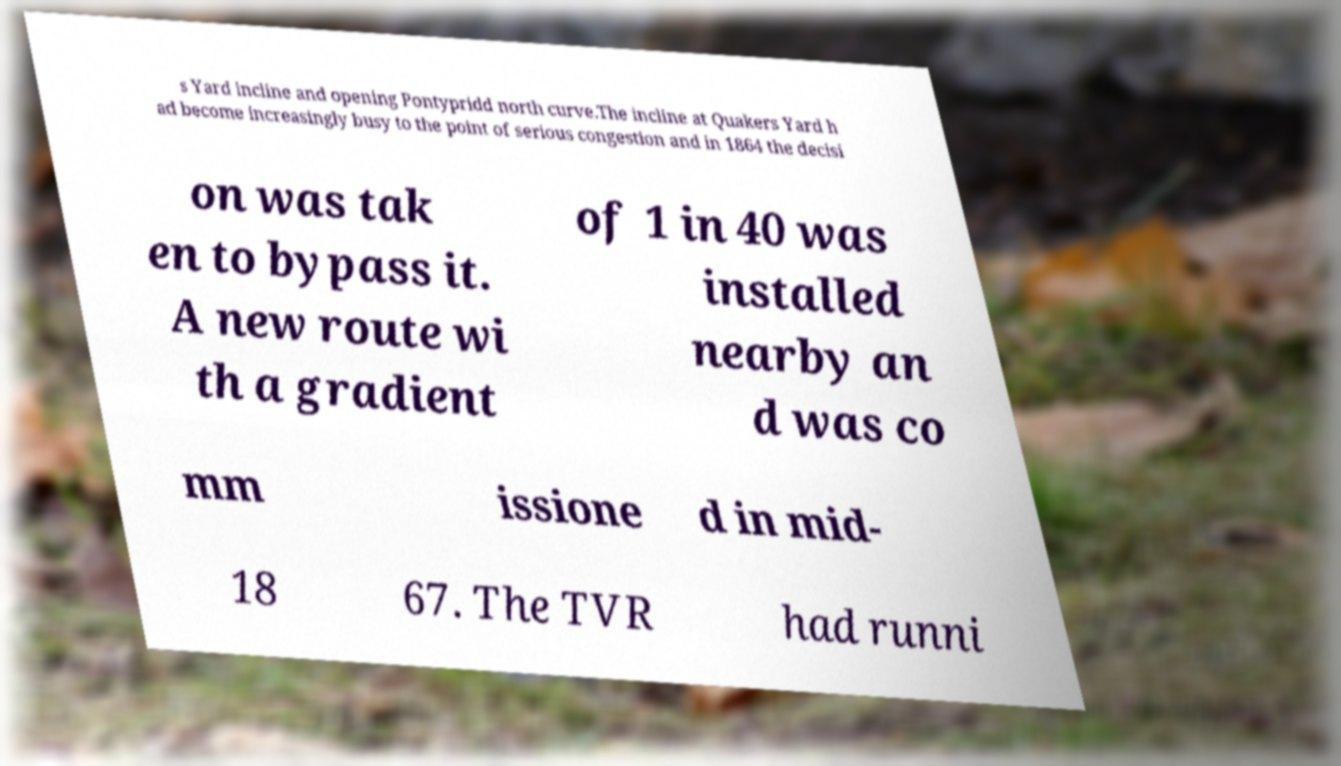For documentation purposes, I need the text within this image transcribed. Could you provide that? s Yard incline and opening Pontypridd north curve.The incline at Quakers Yard h ad become increasingly busy to the point of serious congestion and in 1864 the decisi on was tak en to bypass it. A new route wi th a gradient of 1 in 40 was installed nearby an d was co mm issione d in mid- 18 67. The TVR had runni 